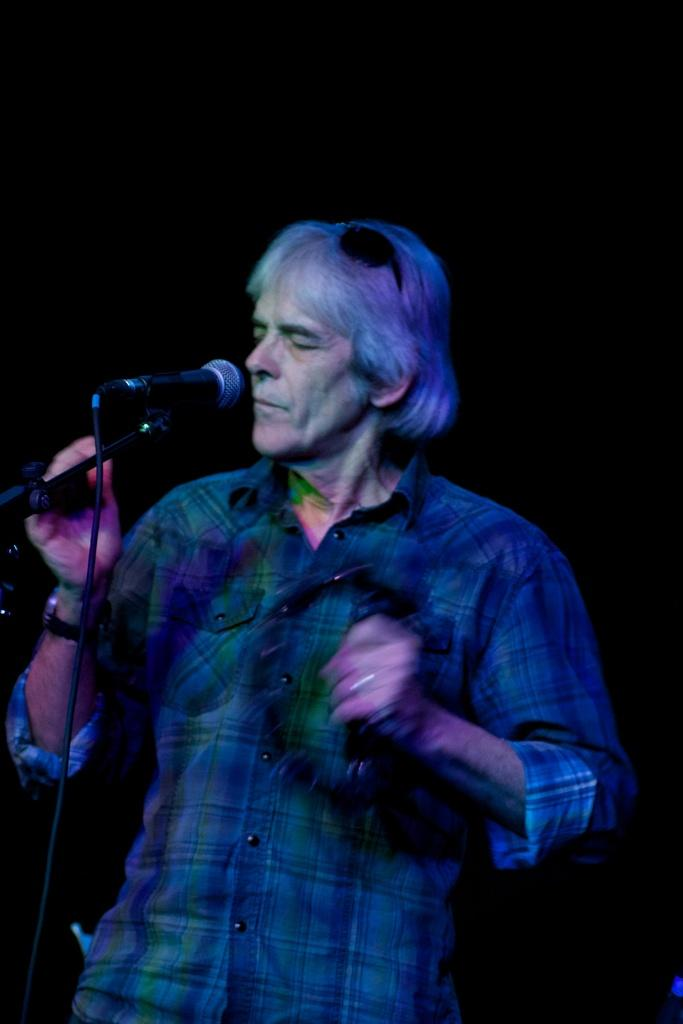What is the main subject of the image? There is a person standing in the center of the image. What object is in front of the person? There is a microphone (mike) in front of the person. What type of yarn is the person using to protest in the image? There is no yarn or protest present in the image; it only features a person standing with a microphone in front of them. 